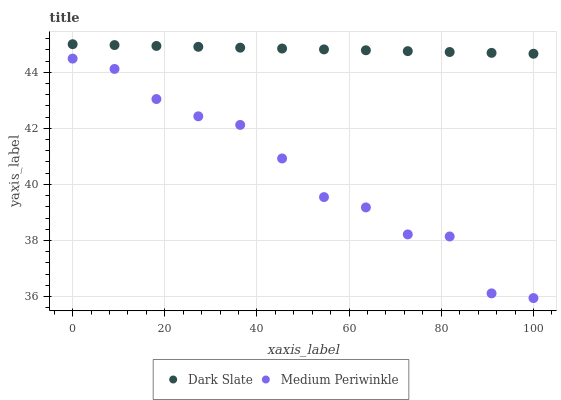Does Medium Periwinkle have the minimum area under the curve?
Answer yes or no. Yes. Does Dark Slate have the maximum area under the curve?
Answer yes or no. Yes. Does Medium Periwinkle have the maximum area under the curve?
Answer yes or no. No. Is Dark Slate the smoothest?
Answer yes or no. Yes. Is Medium Periwinkle the roughest?
Answer yes or no. Yes. Is Medium Periwinkle the smoothest?
Answer yes or no. No. Does Medium Periwinkle have the lowest value?
Answer yes or no. Yes. Does Dark Slate have the highest value?
Answer yes or no. Yes. Does Medium Periwinkle have the highest value?
Answer yes or no. No. Is Medium Periwinkle less than Dark Slate?
Answer yes or no. Yes. Is Dark Slate greater than Medium Periwinkle?
Answer yes or no. Yes. Does Medium Periwinkle intersect Dark Slate?
Answer yes or no. No. 